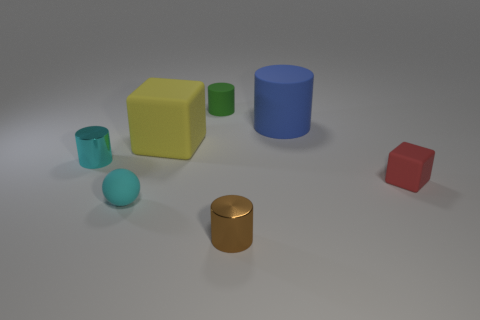How many yellow things are behind the small metallic object that is behind the red rubber cube? There is one yellow object positioned behind the small metallic cylinder, which in turn is located behind the red cube. The yellow object appears to be a cube. 